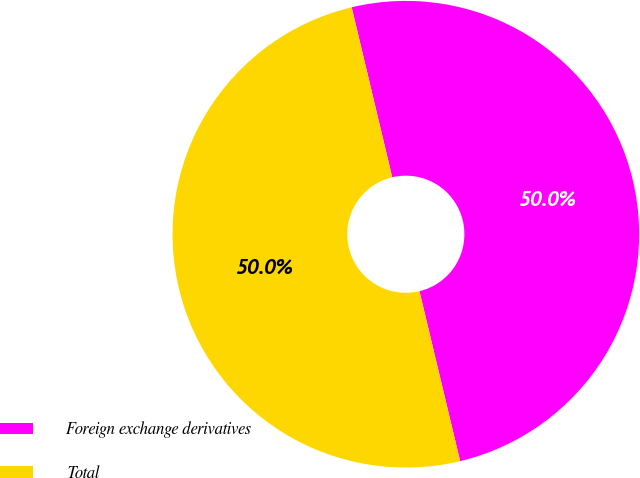Convert chart. <chart><loc_0><loc_0><loc_500><loc_500><pie_chart><fcel>Foreign exchange derivatives<fcel>Total<nl><fcel>49.99%<fcel>50.01%<nl></chart> 